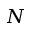<formula> <loc_0><loc_0><loc_500><loc_500>N</formula> 